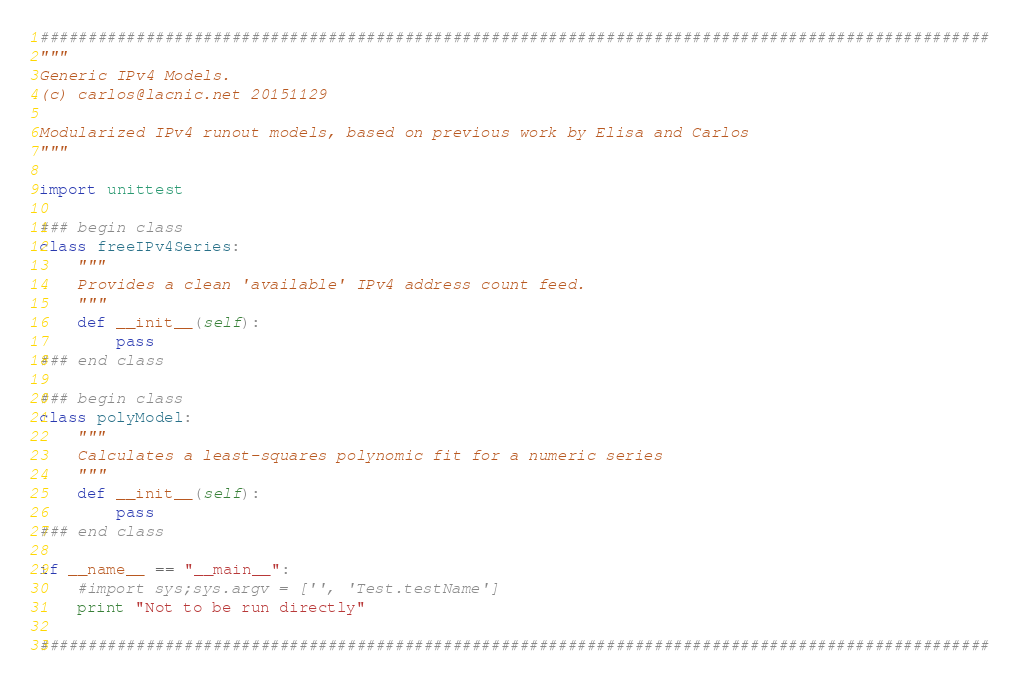<code> <loc_0><loc_0><loc_500><loc_500><_Python_>###################################################################################################
"""
Generic IPv4 Models.
(c) carlos@lacnic.net 20151129

Modularized IPv4 runout models, based on previous work by Elisa and Carlos
"""

import unittest

### begin class
class freeIPv4Series:
    """
    Provides a clean 'available' IPv4 address count feed.
    """
    def __init__(self):
        pass
### end class

### begin class
class polyModel:
    """
    Calculates a least-squares polynomic fit for a numeric series
    """
    def __init__(self):
        pass
### end class

if __name__ == "__main__":
    #import sys;sys.argv = ['', 'Test.testName']
    print "Not to be run directly"

###################################################################################################
</code> 